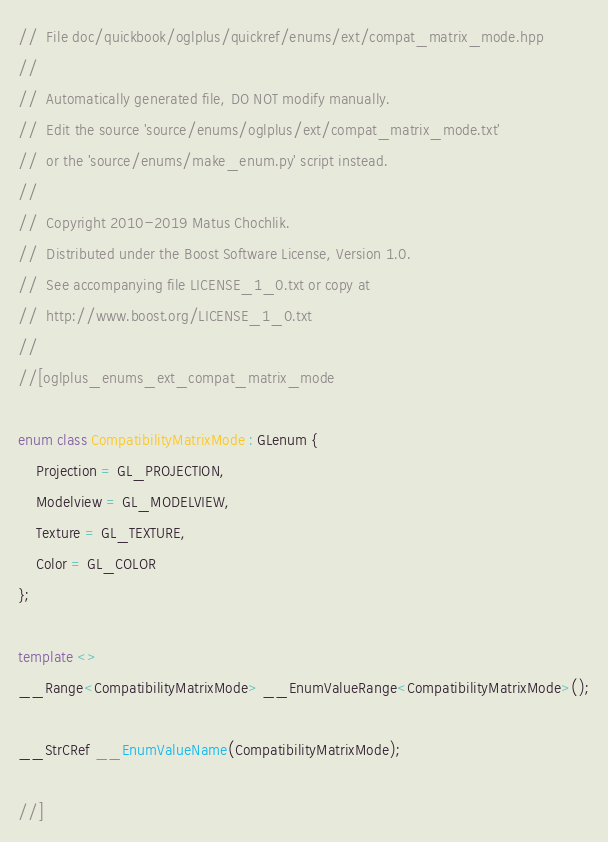<code> <loc_0><loc_0><loc_500><loc_500><_C++_>//  File doc/quickbook/oglplus/quickref/enums/ext/compat_matrix_mode.hpp
//
//  Automatically generated file, DO NOT modify manually.
//  Edit the source 'source/enums/oglplus/ext/compat_matrix_mode.txt'
//  or the 'source/enums/make_enum.py' script instead.
//
//  Copyright 2010-2019 Matus Chochlik.
//  Distributed under the Boost Software License, Version 1.0.
//  See accompanying file LICENSE_1_0.txt or copy at
//  http://www.boost.org/LICENSE_1_0.txt
//
//[oglplus_enums_ext_compat_matrix_mode

enum class CompatibilityMatrixMode : GLenum {
    Projection = GL_PROJECTION,
    Modelview = GL_MODELVIEW,
    Texture = GL_TEXTURE,
    Color = GL_COLOR
};

template <>
__Range<CompatibilityMatrixMode> __EnumValueRange<CompatibilityMatrixMode>();

__StrCRef __EnumValueName(CompatibilityMatrixMode);

//]
</code> 